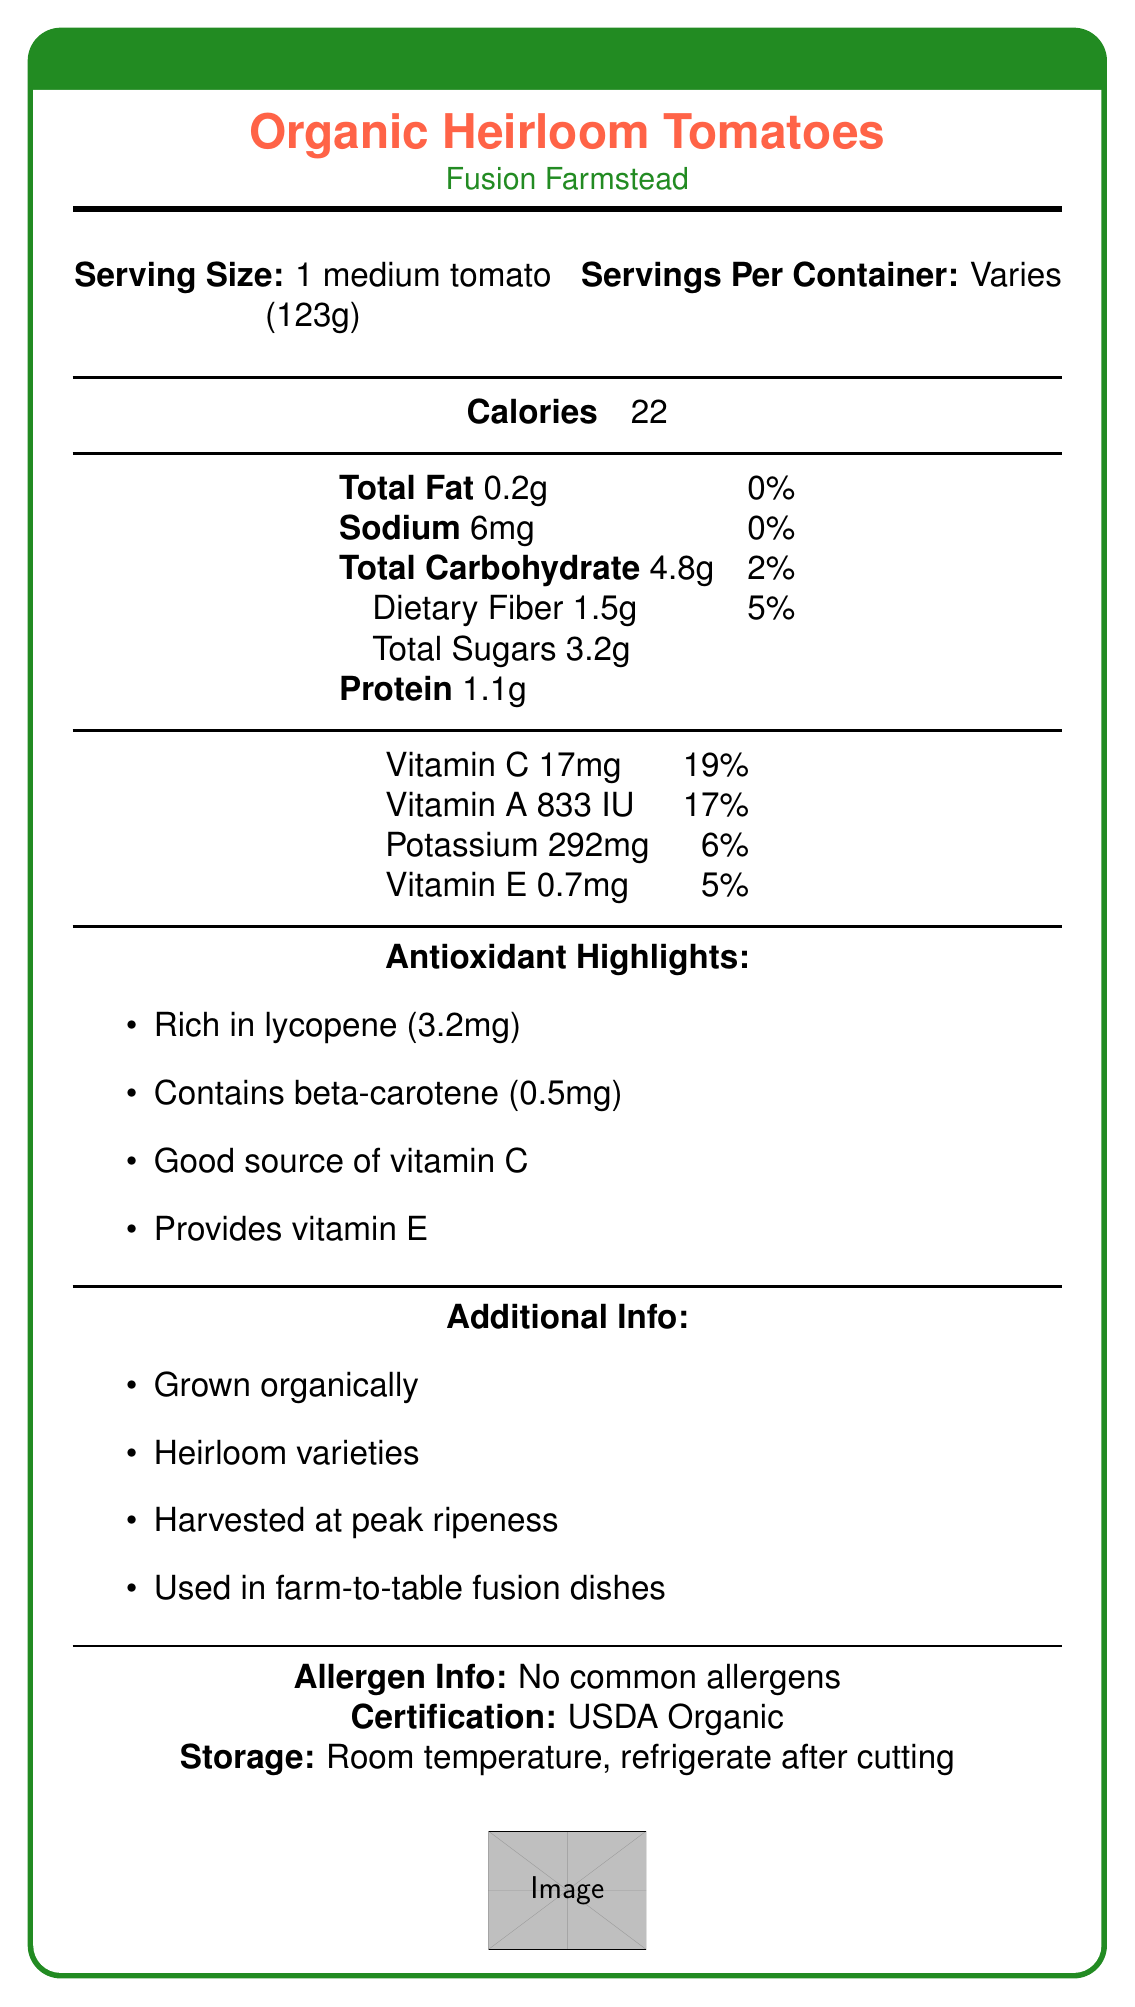what is the calorie count per serving size of 1 medium tomato? The document specifies that the calorie count is 22 for 1 medium tomato (123g).
Answer: 22 how much total fat is in one serving of organic heirloom tomatoes? The nutrition facts label indicates that the total fat content per serving (123g) is 0.2g.
Answer: 0.2g what percentage of the daily value does the dietary fiber content represent? The document states that one serving of dietary fiber is 1.5g, which represents 5% of the daily value.
Answer: 5% what is the amount of sodium per serving size? The label lists the sodium content as 6mg per serving (123g).
Answer: 6mg how much beta-carotene is present in one serving of organic heirloom tomatoes? The document mentions that one serving contains 0.5mg of beta-carotene.
Answer: 0.5mg which vitamin is present in the highest amount by daily value percentage? A. Vitamin C B. Vitamin A C. Vitamin E The label specifies Vitamin C at 17mg or 19% of the daily value, which is higher than Vitamin A (17%) and Vitamin E (5%).
Answer: A what is the protein content in one serving? The nutrition facts label lists the protein content as 1.1g per serving (123g).
Answer: 1.1g which of the following statements is true about organic heirloom tomatoes? A. They contain no calcium B. They contain synthetic pesticides C. They are rich in antioxidants D. They are processed The document emphasizes that these tomatoes are rich in antioxidants and grown organically without synthetic pesticides or fertilizers.
Answer: C what are the antioxidant highlights mentioned? The document points out four antioxidants: lycopene, beta-carotene, vitamin C, and vitamin E.
Answer: Rich in lycopene, contains beta-carotene, good source of vitamin C, provides vitamin E are the organic heirloom tomatoes certified organic? The document confirms that these tomatoes are USDA Organic certified.
Answer: Yes summarize the main features of the organic heirloom tomatoes described in the document. The document provides comprehensive information about the nutritional content, benefits, and organic nature of heirloom tomatoes, emphasizing their health benefits and superior quality.
Answer: The document describes organic heirloom tomatoes from Fusion Farmstead, detailing their nutritional content, antioxidant highlights, and additional info regarding their organic growth and superior flavor. The nutrition label lists low calories, minimal fat, and highlights antioxidants like lycopene, beta-carotene, vitamin C, and vitamin E. They are grown without synthetic pesticides, harvested at peak ripeness, and used in farm-to-table fusion dishes. how should the organic heirloom tomatoes be stored after being cut? According to the storage instructions, the tomatoes should be refrigerated after cutting.
Answer: Refrigerate can we determine the exact number of servings per container based on the document? The document states that the number of servings per container varies, so the exact number cannot be determined.
Answer: No what is the daily value percentage of potassium in one serving? The food label indicates that one serving contains 292mg of potassium, which is 6% of the daily value.
Answer: 6% does the document mention any common allergens in the organic heirloom tomatoes? The document explicitly states that there are no common allergens in the organic heirloom tomatoes.
Answer: No how are these heirloom tomatoes grown? A. Using synthetic pesticides B. Organically C. Indoors D. Hydroponically The additional information section of the document states that the tomatoes are grown organically without synthetic pesticides or fertilizers.
Answer: B 